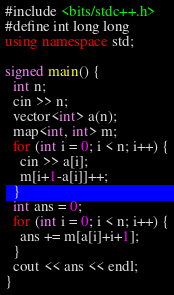<code> <loc_0><loc_0><loc_500><loc_500><_C++_>#include <bits/stdc++.h>
#define int long long
using namespace std;

signed main() {
  int n;
  cin >> n;
  vector<int> a(n);
  map<int, int> m;
  for (int i = 0; i < n; i++) {
    cin >> a[i];
    m[i+1-a[i]]++;
  }
  int ans = 0;
  for (int i = 0; i < n; i++) {
    ans += m[a[i]+i+1];
  }
  cout << ans << endl;
}
</code> 